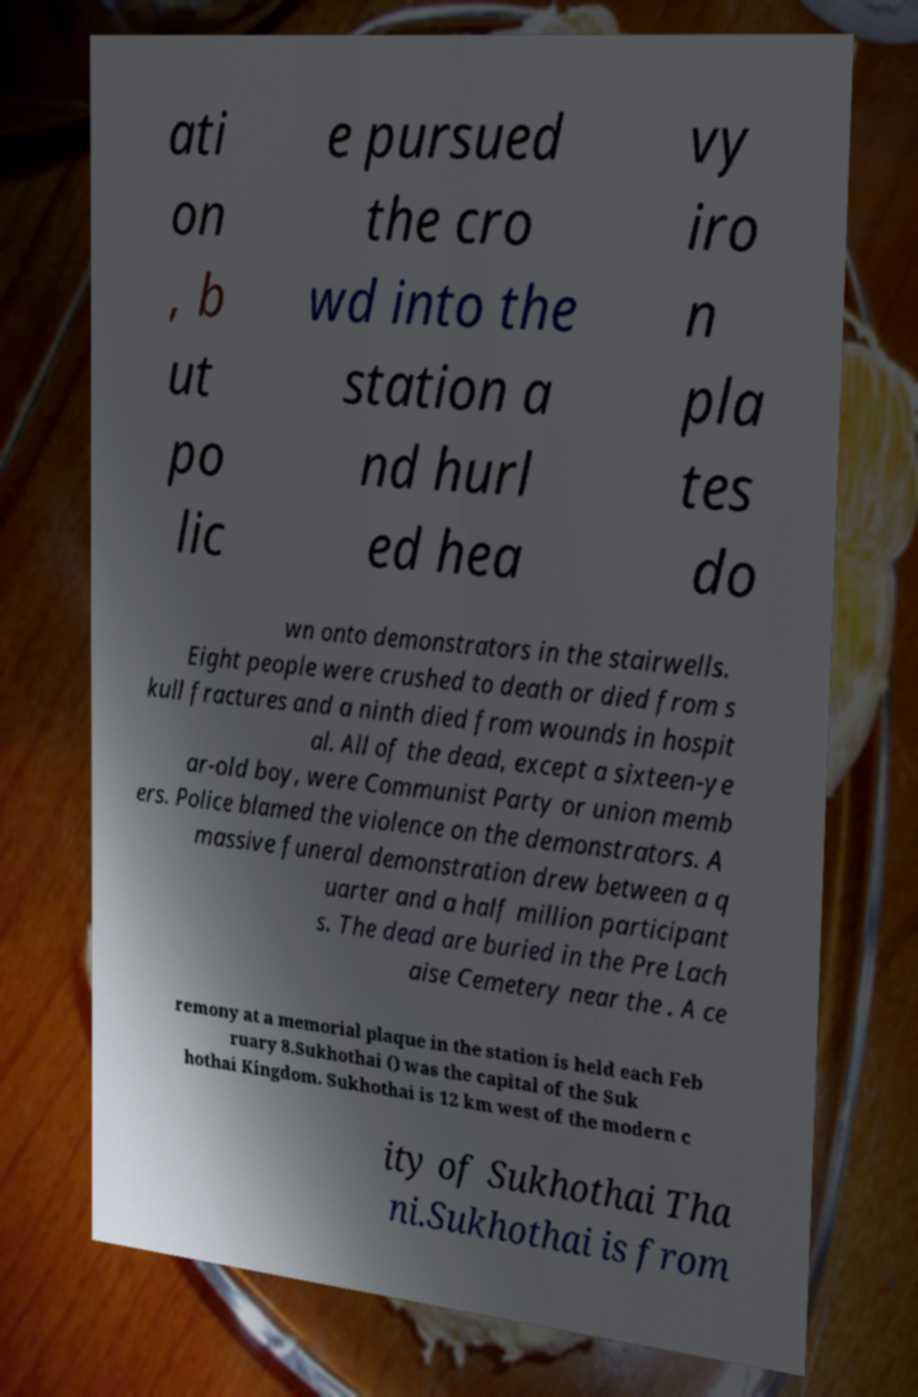Please read and relay the text visible in this image. What does it say? ati on , b ut po lic e pursued the cro wd into the station a nd hurl ed hea vy iro n pla tes do wn onto demonstrators in the stairwells. Eight people were crushed to death or died from s kull fractures and a ninth died from wounds in hospit al. All of the dead, except a sixteen-ye ar-old boy, were Communist Party or union memb ers. Police blamed the violence on the demonstrators. A massive funeral demonstration drew between a q uarter and a half million participant s. The dead are buried in the Pre Lach aise Cemetery near the . A ce remony at a memorial plaque in the station is held each Feb ruary 8.Sukhothai () was the capital of the Suk hothai Kingdom. Sukhothai is 12 km west of the modern c ity of Sukhothai Tha ni.Sukhothai is from 